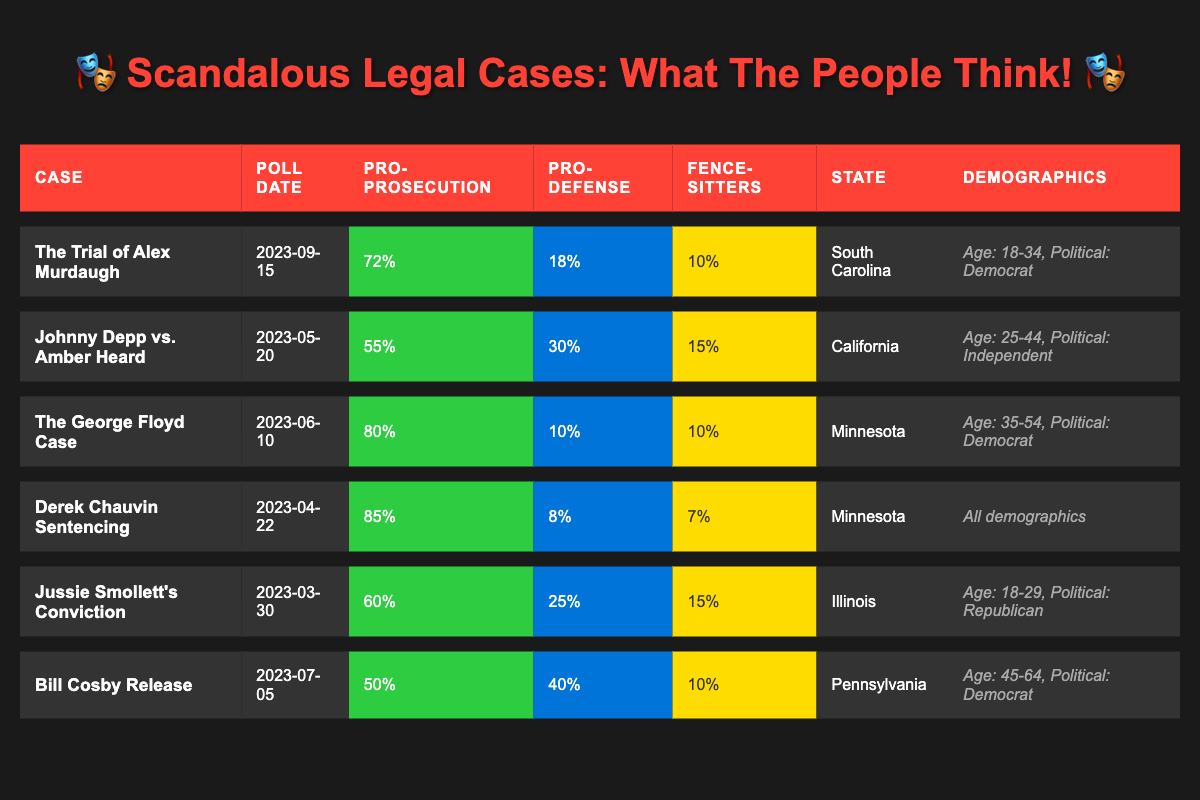What percentage of the public supported the prosecution in the Derek Chauvin sentencing case? The table shows that 85% of respondents supported the prosecution in the Derek Chauvin sentencing case.
Answer: 85% Which case had the highest support for the prosecution? The Derek Chauvin sentencing case had the highest support for the prosecution at 85%.
Answer: Derek Chauvin sentencing In which state was the poll conducted that showed 80% support for the prosecution? The poll showing 80% support for the prosecution was conducted in Minnesota for the George Floyd case.
Answer: Minnesota What is the difference in support for the prosecution between the George Floyd case and Jussie Smollett's conviction? For the George Floyd case, support for prosecution is 80%, while for Jussie Smollett's conviction, it's 60%. The difference is 80% - 60% = 20%.
Answer: 20% Are there any cases where the support for defense is greater than the support for prosecution? In the Bill Cosby Release case, support for defense (40%) is greater than support for prosecution (50%). The answer is no, as support for defense is not greater in any case.
Answer: No Which demographic had the highest support for prosecution in the Alex Murdaugh trial? The demographic shown for the Alex Murdaugh trial is age group 18-34, with a 72% support for prosecution.
Answer: 72% (Age 18-34) What is the average support for prosecution across all cases listed? To find the average support, sum the percentages (72 + 55 + 80 + 85 + 60 + 50) = 402 and then divide by 6 cases: 402 / 6 = 67%.
Answer: 67% What percentage of respondents were undecided in the Johnny Depp vs. Amber Heard case? The table indicates that 15% of respondents were undecided in the Johnny Depp vs. Amber Heard case.
Answer: 15% How many cases showed less than 20% support for defense? The Derek Chauvin sentencing case (8%) and the George Floyd case (10%) both showed less than 20% support for defense. Therefore, there are two cases.
Answer: 2 Is there a case where the support for prosecution was equal to or less than the support for defense? In the Bill Cosby Release case, support for prosecution was 50% and support for defense was 40%, thus it is true that the support for prosecution is greater.
Answer: No How many cases had an undecided response of 10%? Looking at the table, both the Trial of Alex Murdaugh and the George Floyd Case show an undecided response of 10%. So, there are two such cases.
Answer: 2 